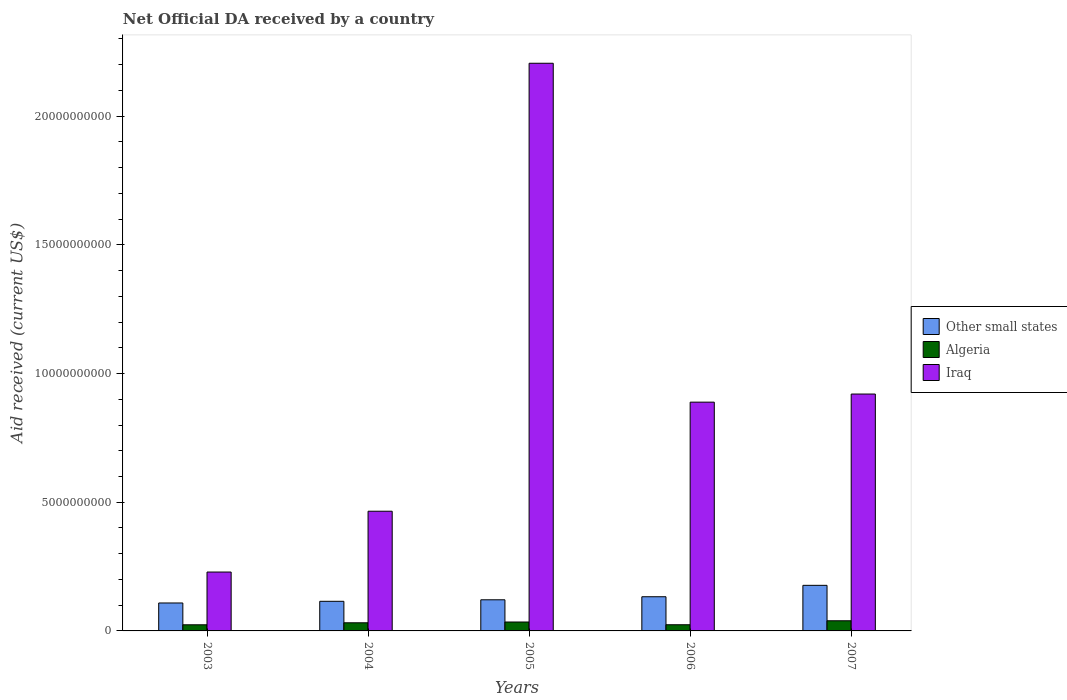How many different coloured bars are there?
Offer a terse response. 3. How many groups of bars are there?
Provide a succinct answer. 5. Are the number of bars per tick equal to the number of legend labels?
Make the answer very short. Yes. What is the net official development assistance aid received in Algeria in 2007?
Offer a very short reply. 3.94e+08. Across all years, what is the maximum net official development assistance aid received in Algeria?
Your answer should be compact. 3.94e+08. Across all years, what is the minimum net official development assistance aid received in Algeria?
Provide a short and direct response. 2.38e+08. In which year was the net official development assistance aid received in Other small states maximum?
Your answer should be compact. 2007. In which year was the net official development assistance aid received in Algeria minimum?
Your answer should be very brief. 2003. What is the total net official development assistance aid received in Algeria in the graph?
Your response must be concise. 1.54e+09. What is the difference between the net official development assistance aid received in Iraq in 2003 and that in 2004?
Ensure brevity in your answer.  -2.36e+09. What is the difference between the net official development assistance aid received in Algeria in 2003 and the net official development assistance aid received in Other small states in 2004?
Provide a succinct answer. -9.13e+08. What is the average net official development assistance aid received in Iraq per year?
Give a very brief answer. 9.42e+09. In the year 2005, what is the difference between the net official development assistance aid received in Other small states and net official development assistance aid received in Algeria?
Your answer should be compact. 8.63e+08. What is the ratio of the net official development assistance aid received in Other small states in 2003 to that in 2006?
Ensure brevity in your answer.  0.82. Is the net official development assistance aid received in Iraq in 2003 less than that in 2004?
Provide a succinct answer. Yes. What is the difference between the highest and the second highest net official development assistance aid received in Iraq?
Give a very brief answer. 1.29e+1. What is the difference between the highest and the lowest net official development assistance aid received in Algeria?
Provide a short and direct response. 1.56e+08. Is the sum of the net official development assistance aid received in Iraq in 2004 and 2006 greater than the maximum net official development assistance aid received in Algeria across all years?
Make the answer very short. Yes. What does the 2nd bar from the left in 2006 represents?
Offer a very short reply. Algeria. What does the 3rd bar from the right in 2005 represents?
Offer a terse response. Other small states. Are all the bars in the graph horizontal?
Provide a short and direct response. No. What is the difference between two consecutive major ticks on the Y-axis?
Give a very brief answer. 5.00e+09. Does the graph contain any zero values?
Offer a very short reply. No. Does the graph contain grids?
Give a very brief answer. No. Where does the legend appear in the graph?
Your response must be concise. Center right. How many legend labels are there?
Provide a short and direct response. 3. What is the title of the graph?
Give a very brief answer. Net Official DA received by a country. Does "Aruba" appear as one of the legend labels in the graph?
Offer a very short reply. No. What is the label or title of the X-axis?
Your response must be concise. Years. What is the label or title of the Y-axis?
Offer a terse response. Aid received (current US$). What is the Aid received (current US$) in Other small states in 2003?
Provide a succinct answer. 1.09e+09. What is the Aid received (current US$) of Algeria in 2003?
Offer a very short reply. 2.38e+08. What is the Aid received (current US$) of Iraq in 2003?
Make the answer very short. 2.29e+09. What is the Aid received (current US$) in Other small states in 2004?
Offer a very short reply. 1.15e+09. What is the Aid received (current US$) in Algeria in 2004?
Offer a terse response. 3.16e+08. What is the Aid received (current US$) of Iraq in 2004?
Keep it short and to the point. 4.65e+09. What is the Aid received (current US$) of Other small states in 2005?
Provide a succinct answer. 1.21e+09. What is the Aid received (current US$) in Algeria in 2005?
Offer a very short reply. 3.47e+08. What is the Aid received (current US$) in Iraq in 2005?
Offer a terse response. 2.21e+1. What is the Aid received (current US$) of Other small states in 2006?
Offer a terse response. 1.33e+09. What is the Aid received (current US$) in Algeria in 2006?
Offer a very short reply. 2.40e+08. What is the Aid received (current US$) of Iraq in 2006?
Ensure brevity in your answer.  8.89e+09. What is the Aid received (current US$) in Other small states in 2007?
Give a very brief answer. 1.77e+09. What is the Aid received (current US$) of Algeria in 2007?
Offer a very short reply. 3.94e+08. What is the Aid received (current US$) in Iraq in 2007?
Make the answer very short. 9.20e+09. Across all years, what is the maximum Aid received (current US$) of Other small states?
Your answer should be compact. 1.77e+09. Across all years, what is the maximum Aid received (current US$) in Algeria?
Keep it short and to the point. 3.94e+08. Across all years, what is the maximum Aid received (current US$) in Iraq?
Offer a very short reply. 2.21e+1. Across all years, what is the minimum Aid received (current US$) of Other small states?
Make the answer very short. 1.09e+09. Across all years, what is the minimum Aid received (current US$) of Algeria?
Offer a very short reply. 2.38e+08. Across all years, what is the minimum Aid received (current US$) in Iraq?
Your answer should be compact. 2.29e+09. What is the total Aid received (current US$) of Other small states in the graph?
Your answer should be very brief. 6.55e+09. What is the total Aid received (current US$) in Algeria in the graph?
Offer a very short reply. 1.54e+09. What is the total Aid received (current US$) of Iraq in the graph?
Offer a terse response. 4.71e+1. What is the difference between the Aid received (current US$) in Other small states in 2003 and that in 2004?
Give a very brief answer. -6.51e+07. What is the difference between the Aid received (current US$) of Algeria in 2003 and that in 2004?
Offer a terse response. -7.81e+07. What is the difference between the Aid received (current US$) of Iraq in 2003 and that in 2004?
Give a very brief answer. -2.36e+09. What is the difference between the Aid received (current US$) of Other small states in 2003 and that in 2005?
Offer a terse response. -1.24e+08. What is the difference between the Aid received (current US$) of Algeria in 2003 and that in 2005?
Make the answer very short. -1.08e+08. What is the difference between the Aid received (current US$) of Iraq in 2003 and that in 2005?
Give a very brief answer. -1.98e+1. What is the difference between the Aid received (current US$) of Other small states in 2003 and that in 2006?
Make the answer very short. -2.43e+08. What is the difference between the Aid received (current US$) in Algeria in 2003 and that in 2006?
Your answer should be compact. -1.79e+06. What is the difference between the Aid received (current US$) of Iraq in 2003 and that in 2006?
Provide a succinct answer. -6.60e+09. What is the difference between the Aid received (current US$) in Other small states in 2003 and that in 2007?
Offer a very short reply. -6.86e+08. What is the difference between the Aid received (current US$) in Algeria in 2003 and that in 2007?
Give a very brief answer. -1.56e+08. What is the difference between the Aid received (current US$) of Iraq in 2003 and that in 2007?
Provide a succinct answer. -6.92e+09. What is the difference between the Aid received (current US$) of Other small states in 2004 and that in 2005?
Give a very brief answer. -5.88e+07. What is the difference between the Aid received (current US$) of Algeria in 2004 and that in 2005?
Your answer should be compact. -3.04e+07. What is the difference between the Aid received (current US$) in Iraq in 2004 and that in 2005?
Offer a very short reply. -1.74e+1. What is the difference between the Aid received (current US$) of Other small states in 2004 and that in 2006?
Keep it short and to the point. -1.77e+08. What is the difference between the Aid received (current US$) of Algeria in 2004 and that in 2006?
Give a very brief answer. 7.63e+07. What is the difference between the Aid received (current US$) in Iraq in 2004 and that in 2006?
Give a very brief answer. -4.24e+09. What is the difference between the Aid received (current US$) in Other small states in 2004 and that in 2007?
Ensure brevity in your answer.  -6.21e+08. What is the difference between the Aid received (current US$) of Algeria in 2004 and that in 2007?
Offer a very short reply. -7.81e+07. What is the difference between the Aid received (current US$) in Iraq in 2004 and that in 2007?
Provide a succinct answer. -4.55e+09. What is the difference between the Aid received (current US$) of Other small states in 2005 and that in 2006?
Offer a terse response. -1.19e+08. What is the difference between the Aid received (current US$) in Algeria in 2005 and that in 2006?
Give a very brief answer. 1.07e+08. What is the difference between the Aid received (current US$) in Iraq in 2005 and that in 2006?
Ensure brevity in your answer.  1.32e+1. What is the difference between the Aid received (current US$) of Other small states in 2005 and that in 2007?
Ensure brevity in your answer.  -5.62e+08. What is the difference between the Aid received (current US$) of Algeria in 2005 and that in 2007?
Your answer should be compact. -4.77e+07. What is the difference between the Aid received (current US$) in Iraq in 2005 and that in 2007?
Provide a succinct answer. 1.29e+1. What is the difference between the Aid received (current US$) in Other small states in 2006 and that in 2007?
Keep it short and to the point. -4.43e+08. What is the difference between the Aid received (current US$) of Algeria in 2006 and that in 2007?
Your response must be concise. -1.54e+08. What is the difference between the Aid received (current US$) in Iraq in 2006 and that in 2007?
Make the answer very short. -3.15e+08. What is the difference between the Aid received (current US$) in Other small states in 2003 and the Aid received (current US$) in Algeria in 2004?
Ensure brevity in your answer.  7.70e+08. What is the difference between the Aid received (current US$) of Other small states in 2003 and the Aid received (current US$) of Iraq in 2004?
Give a very brief answer. -3.56e+09. What is the difference between the Aid received (current US$) of Algeria in 2003 and the Aid received (current US$) of Iraq in 2004?
Your answer should be compact. -4.41e+09. What is the difference between the Aid received (current US$) in Other small states in 2003 and the Aid received (current US$) in Algeria in 2005?
Make the answer very short. 7.39e+08. What is the difference between the Aid received (current US$) in Other small states in 2003 and the Aid received (current US$) in Iraq in 2005?
Offer a terse response. -2.10e+1. What is the difference between the Aid received (current US$) in Algeria in 2003 and the Aid received (current US$) in Iraq in 2005?
Your answer should be compact. -2.18e+1. What is the difference between the Aid received (current US$) of Other small states in 2003 and the Aid received (current US$) of Algeria in 2006?
Your answer should be very brief. 8.46e+08. What is the difference between the Aid received (current US$) of Other small states in 2003 and the Aid received (current US$) of Iraq in 2006?
Ensure brevity in your answer.  -7.80e+09. What is the difference between the Aid received (current US$) of Algeria in 2003 and the Aid received (current US$) of Iraq in 2006?
Offer a terse response. -8.65e+09. What is the difference between the Aid received (current US$) in Other small states in 2003 and the Aid received (current US$) in Algeria in 2007?
Your answer should be very brief. 6.91e+08. What is the difference between the Aid received (current US$) of Other small states in 2003 and the Aid received (current US$) of Iraq in 2007?
Offer a terse response. -8.12e+09. What is the difference between the Aid received (current US$) in Algeria in 2003 and the Aid received (current US$) in Iraq in 2007?
Provide a short and direct response. -8.97e+09. What is the difference between the Aid received (current US$) in Other small states in 2004 and the Aid received (current US$) in Algeria in 2005?
Provide a short and direct response. 8.04e+08. What is the difference between the Aid received (current US$) of Other small states in 2004 and the Aid received (current US$) of Iraq in 2005?
Your response must be concise. -2.09e+1. What is the difference between the Aid received (current US$) of Algeria in 2004 and the Aid received (current US$) of Iraq in 2005?
Provide a short and direct response. -2.17e+1. What is the difference between the Aid received (current US$) of Other small states in 2004 and the Aid received (current US$) of Algeria in 2006?
Offer a very short reply. 9.11e+08. What is the difference between the Aid received (current US$) in Other small states in 2004 and the Aid received (current US$) in Iraq in 2006?
Your response must be concise. -7.74e+09. What is the difference between the Aid received (current US$) in Algeria in 2004 and the Aid received (current US$) in Iraq in 2006?
Provide a short and direct response. -8.57e+09. What is the difference between the Aid received (current US$) of Other small states in 2004 and the Aid received (current US$) of Algeria in 2007?
Make the answer very short. 7.57e+08. What is the difference between the Aid received (current US$) in Other small states in 2004 and the Aid received (current US$) in Iraq in 2007?
Keep it short and to the point. -8.05e+09. What is the difference between the Aid received (current US$) of Algeria in 2004 and the Aid received (current US$) of Iraq in 2007?
Offer a very short reply. -8.89e+09. What is the difference between the Aid received (current US$) in Other small states in 2005 and the Aid received (current US$) in Algeria in 2006?
Your response must be concise. 9.70e+08. What is the difference between the Aid received (current US$) of Other small states in 2005 and the Aid received (current US$) of Iraq in 2006?
Ensure brevity in your answer.  -7.68e+09. What is the difference between the Aid received (current US$) in Algeria in 2005 and the Aid received (current US$) in Iraq in 2006?
Your answer should be compact. -8.54e+09. What is the difference between the Aid received (current US$) of Other small states in 2005 and the Aid received (current US$) of Algeria in 2007?
Your response must be concise. 8.15e+08. What is the difference between the Aid received (current US$) of Other small states in 2005 and the Aid received (current US$) of Iraq in 2007?
Offer a terse response. -7.99e+09. What is the difference between the Aid received (current US$) in Algeria in 2005 and the Aid received (current US$) in Iraq in 2007?
Your answer should be compact. -8.86e+09. What is the difference between the Aid received (current US$) of Other small states in 2006 and the Aid received (current US$) of Algeria in 2007?
Offer a very short reply. 9.34e+08. What is the difference between the Aid received (current US$) in Other small states in 2006 and the Aid received (current US$) in Iraq in 2007?
Ensure brevity in your answer.  -7.88e+09. What is the difference between the Aid received (current US$) of Algeria in 2006 and the Aid received (current US$) of Iraq in 2007?
Ensure brevity in your answer.  -8.96e+09. What is the average Aid received (current US$) of Other small states per year?
Give a very brief answer. 1.31e+09. What is the average Aid received (current US$) in Algeria per year?
Give a very brief answer. 3.07e+08. What is the average Aid received (current US$) in Iraq per year?
Ensure brevity in your answer.  9.42e+09. In the year 2003, what is the difference between the Aid received (current US$) of Other small states and Aid received (current US$) of Algeria?
Provide a succinct answer. 8.48e+08. In the year 2003, what is the difference between the Aid received (current US$) in Other small states and Aid received (current US$) in Iraq?
Your answer should be very brief. -1.20e+09. In the year 2003, what is the difference between the Aid received (current US$) in Algeria and Aid received (current US$) in Iraq?
Ensure brevity in your answer.  -2.05e+09. In the year 2004, what is the difference between the Aid received (current US$) in Other small states and Aid received (current US$) in Algeria?
Keep it short and to the point. 8.35e+08. In the year 2004, what is the difference between the Aid received (current US$) in Other small states and Aid received (current US$) in Iraq?
Your answer should be compact. -3.50e+09. In the year 2004, what is the difference between the Aid received (current US$) in Algeria and Aid received (current US$) in Iraq?
Keep it short and to the point. -4.33e+09. In the year 2005, what is the difference between the Aid received (current US$) of Other small states and Aid received (current US$) of Algeria?
Give a very brief answer. 8.63e+08. In the year 2005, what is the difference between the Aid received (current US$) of Other small states and Aid received (current US$) of Iraq?
Keep it short and to the point. -2.08e+1. In the year 2005, what is the difference between the Aid received (current US$) of Algeria and Aid received (current US$) of Iraq?
Offer a terse response. -2.17e+1. In the year 2006, what is the difference between the Aid received (current US$) of Other small states and Aid received (current US$) of Algeria?
Keep it short and to the point. 1.09e+09. In the year 2006, what is the difference between the Aid received (current US$) in Other small states and Aid received (current US$) in Iraq?
Make the answer very short. -7.56e+09. In the year 2006, what is the difference between the Aid received (current US$) of Algeria and Aid received (current US$) of Iraq?
Make the answer very short. -8.65e+09. In the year 2007, what is the difference between the Aid received (current US$) in Other small states and Aid received (current US$) in Algeria?
Make the answer very short. 1.38e+09. In the year 2007, what is the difference between the Aid received (current US$) in Other small states and Aid received (current US$) in Iraq?
Provide a short and direct response. -7.43e+09. In the year 2007, what is the difference between the Aid received (current US$) in Algeria and Aid received (current US$) in Iraq?
Offer a very short reply. -8.81e+09. What is the ratio of the Aid received (current US$) in Other small states in 2003 to that in 2004?
Ensure brevity in your answer.  0.94. What is the ratio of the Aid received (current US$) in Algeria in 2003 to that in 2004?
Ensure brevity in your answer.  0.75. What is the ratio of the Aid received (current US$) in Iraq in 2003 to that in 2004?
Offer a very short reply. 0.49. What is the ratio of the Aid received (current US$) of Other small states in 2003 to that in 2005?
Offer a very short reply. 0.9. What is the ratio of the Aid received (current US$) of Algeria in 2003 to that in 2005?
Your answer should be very brief. 0.69. What is the ratio of the Aid received (current US$) of Iraq in 2003 to that in 2005?
Offer a terse response. 0.1. What is the ratio of the Aid received (current US$) of Other small states in 2003 to that in 2006?
Ensure brevity in your answer.  0.82. What is the ratio of the Aid received (current US$) of Algeria in 2003 to that in 2006?
Ensure brevity in your answer.  0.99. What is the ratio of the Aid received (current US$) in Iraq in 2003 to that in 2006?
Keep it short and to the point. 0.26. What is the ratio of the Aid received (current US$) in Other small states in 2003 to that in 2007?
Your answer should be compact. 0.61. What is the ratio of the Aid received (current US$) of Algeria in 2003 to that in 2007?
Offer a terse response. 0.6. What is the ratio of the Aid received (current US$) in Iraq in 2003 to that in 2007?
Your answer should be very brief. 0.25. What is the ratio of the Aid received (current US$) of Other small states in 2004 to that in 2005?
Give a very brief answer. 0.95. What is the ratio of the Aid received (current US$) of Algeria in 2004 to that in 2005?
Provide a succinct answer. 0.91. What is the ratio of the Aid received (current US$) in Iraq in 2004 to that in 2005?
Your answer should be compact. 0.21. What is the ratio of the Aid received (current US$) in Other small states in 2004 to that in 2006?
Your answer should be compact. 0.87. What is the ratio of the Aid received (current US$) of Algeria in 2004 to that in 2006?
Offer a very short reply. 1.32. What is the ratio of the Aid received (current US$) in Iraq in 2004 to that in 2006?
Offer a terse response. 0.52. What is the ratio of the Aid received (current US$) in Other small states in 2004 to that in 2007?
Offer a terse response. 0.65. What is the ratio of the Aid received (current US$) in Algeria in 2004 to that in 2007?
Your response must be concise. 0.8. What is the ratio of the Aid received (current US$) in Iraq in 2004 to that in 2007?
Your answer should be very brief. 0.51. What is the ratio of the Aid received (current US$) of Other small states in 2005 to that in 2006?
Your response must be concise. 0.91. What is the ratio of the Aid received (current US$) in Algeria in 2005 to that in 2006?
Ensure brevity in your answer.  1.44. What is the ratio of the Aid received (current US$) in Iraq in 2005 to that in 2006?
Offer a very short reply. 2.48. What is the ratio of the Aid received (current US$) in Other small states in 2005 to that in 2007?
Your answer should be compact. 0.68. What is the ratio of the Aid received (current US$) of Algeria in 2005 to that in 2007?
Provide a short and direct response. 0.88. What is the ratio of the Aid received (current US$) of Iraq in 2005 to that in 2007?
Provide a succinct answer. 2.4. What is the ratio of the Aid received (current US$) in Other small states in 2006 to that in 2007?
Your answer should be compact. 0.75. What is the ratio of the Aid received (current US$) in Algeria in 2006 to that in 2007?
Your answer should be very brief. 0.61. What is the ratio of the Aid received (current US$) of Iraq in 2006 to that in 2007?
Provide a short and direct response. 0.97. What is the difference between the highest and the second highest Aid received (current US$) of Other small states?
Your answer should be very brief. 4.43e+08. What is the difference between the highest and the second highest Aid received (current US$) of Algeria?
Your answer should be compact. 4.77e+07. What is the difference between the highest and the second highest Aid received (current US$) of Iraq?
Your answer should be compact. 1.29e+1. What is the difference between the highest and the lowest Aid received (current US$) of Other small states?
Give a very brief answer. 6.86e+08. What is the difference between the highest and the lowest Aid received (current US$) in Algeria?
Provide a short and direct response. 1.56e+08. What is the difference between the highest and the lowest Aid received (current US$) of Iraq?
Provide a short and direct response. 1.98e+1. 